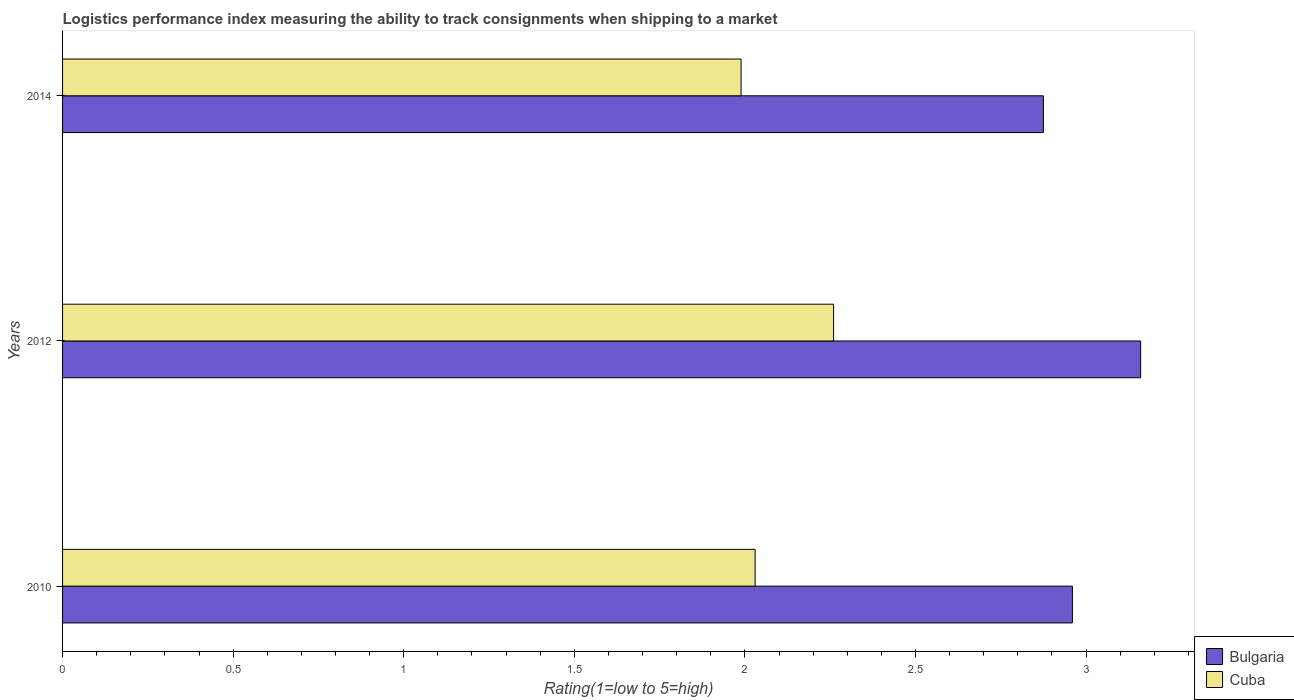How many groups of bars are there?
Provide a short and direct response. 3. How many bars are there on the 2nd tick from the bottom?
Your answer should be compact. 2. What is the Logistic performance index in Bulgaria in 2014?
Ensure brevity in your answer.  2.88. Across all years, what is the maximum Logistic performance index in Cuba?
Offer a terse response. 2.26. Across all years, what is the minimum Logistic performance index in Bulgaria?
Give a very brief answer. 2.88. In which year was the Logistic performance index in Cuba maximum?
Make the answer very short. 2012. In which year was the Logistic performance index in Cuba minimum?
Offer a very short reply. 2014. What is the total Logistic performance index in Bulgaria in the graph?
Provide a short and direct response. 9. What is the difference between the Logistic performance index in Bulgaria in 2010 and that in 2014?
Provide a short and direct response. 0.08. What is the difference between the Logistic performance index in Cuba in 2010 and the Logistic performance index in Bulgaria in 2014?
Your response must be concise. -0.85. What is the average Logistic performance index in Cuba per year?
Give a very brief answer. 2.09. In the year 2010, what is the difference between the Logistic performance index in Cuba and Logistic performance index in Bulgaria?
Offer a very short reply. -0.93. What is the ratio of the Logistic performance index in Cuba in 2010 to that in 2012?
Your answer should be very brief. 0.9. Is the Logistic performance index in Bulgaria in 2012 less than that in 2014?
Provide a short and direct response. No. What is the difference between the highest and the second highest Logistic performance index in Cuba?
Ensure brevity in your answer.  0.23. What is the difference between the highest and the lowest Logistic performance index in Bulgaria?
Keep it short and to the point. 0.29. In how many years, is the Logistic performance index in Cuba greater than the average Logistic performance index in Cuba taken over all years?
Your response must be concise. 1. What does the 2nd bar from the top in 2010 represents?
Your response must be concise. Bulgaria. What does the 2nd bar from the bottom in 2012 represents?
Give a very brief answer. Cuba. How many bars are there?
Your answer should be very brief. 6. Are all the bars in the graph horizontal?
Provide a short and direct response. Yes. Are the values on the major ticks of X-axis written in scientific E-notation?
Offer a terse response. No. Does the graph contain any zero values?
Your answer should be very brief. No. How many legend labels are there?
Provide a succinct answer. 2. How are the legend labels stacked?
Provide a succinct answer. Vertical. What is the title of the graph?
Provide a short and direct response. Logistics performance index measuring the ability to track consignments when shipping to a market. What is the label or title of the X-axis?
Your response must be concise. Rating(1=low to 5=high). What is the Rating(1=low to 5=high) of Bulgaria in 2010?
Your answer should be compact. 2.96. What is the Rating(1=low to 5=high) in Cuba in 2010?
Keep it short and to the point. 2.03. What is the Rating(1=low to 5=high) in Bulgaria in 2012?
Offer a terse response. 3.16. What is the Rating(1=low to 5=high) of Cuba in 2012?
Your response must be concise. 2.26. What is the Rating(1=low to 5=high) in Bulgaria in 2014?
Make the answer very short. 2.88. What is the Rating(1=low to 5=high) of Cuba in 2014?
Provide a short and direct response. 1.99. Across all years, what is the maximum Rating(1=low to 5=high) of Bulgaria?
Provide a succinct answer. 3.16. Across all years, what is the maximum Rating(1=low to 5=high) in Cuba?
Your response must be concise. 2.26. Across all years, what is the minimum Rating(1=low to 5=high) of Bulgaria?
Offer a very short reply. 2.88. Across all years, what is the minimum Rating(1=low to 5=high) of Cuba?
Provide a succinct answer. 1.99. What is the total Rating(1=low to 5=high) of Bulgaria in the graph?
Your response must be concise. 8.99. What is the total Rating(1=low to 5=high) in Cuba in the graph?
Offer a very short reply. 6.28. What is the difference between the Rating(1=low to 5=high) in Bulgaria in 2010 and that in 2012?
Keep it short and to the point. -0.2. What is the difference between the Rating(1=low to 5=high) in Cuba in 2010 and that in 2012?
Your response must be concise. -0.23. What is the difference between the Rating(1=low to 5=high) of Bulgaria in 2010 and that in 2014?
Your response must be concise. 0.09. What is the difference between the Rating(1=low to 5=high) in Cuba in 2010 and that in 2014?
Give a very brief answer. 0.04. What is the difference between the Rating(1=low to 5=high) of Bulgaria in 2012 and that in 2014?
Your answer should be very brief. 0.28. What is the difference between the Rating(1=low to 5=high) of Cuba in 2012 and that in 2014?
Offer a terse response. 0.27. What is the difference between the Rating(1=low to 5=high) of Bulgaria in 2010 and the Rating(1=low to 5=high) of Cuba in 2012?
Give a very brief answer. 0.7. What is the difference between the Rating(1=low to 5=high) in Bulgaria in 2010 and the Rating(1=low to 5=high) in Cuba in 2014?
Give a very brief answer. 0.97. What is the difference between the Rating(1=low to 5=high) of Bulgaria in 2012 and the Rating(1=low to 5=high) of Cuba in 2014?
Provide a succinct answer. 1.17. What is the average Rating(1=low to 5=high) in Bulgaria per year?
Provide a succinct answer. 3. What is the average Rating(1=low to 5=high) in Cuba per year?
Offer a terse response. 2.09. In the year 2010, what is the difference between the Rating(1=low to 5=high) of Bulgaria and Rating(1=low to 5=high) of Cuba?
Keep it short and to the point. 0.93. In the year 2014, what is the difference between the Rating(1=low to 5=high) of Bulgaria and Rating(1=low to 5=high) of Cuba?
Keep it short and to the point. 0.89. What is the ratio of the Rating(1=low to 5=high) of Bulgaria in 2010 to that in 2012?
Your answer should be compact. 0.94. What is the ratio of the Rating(1=low to 5=high) in Cuba in 2010 to that in 2012?
Your answer should be compact. 0.9. What is the ratio of the Rating(1=low to 5=high) in Bulgaria in 2010 to that in 2014?
Provide a succinct answer. 1.03. What is the ratio of the Rating(1=low to 5=high) in Cuba in 2010 to that in 2014?
Ensure brevity in your answer.  1.02. What is the ratio of the Rating(1=low to 5=high) in Bulgaria in 2012 to that in 2014?
Offer a terse response. 1.1. What is the ratio of the Rating(1=low to 5=high) in Cuba in 2012 to that in 2014?
Your answer should be very brief. 1.14. What is the difference between the highest and the second highest Rating(1=low to 5=high) of Cuba?
Give a very brief answer. 0.23. What is the difference between the highest and the lowest Rating(1=low to 5=high) in Bulgaria?
Your answer should be very brief. 0.28. What is the difference between the highest and the lowest Rating(1=low to 5=high) of Cuba?
Offer a terse response. 0.27. 